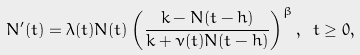<formula> <loc_0><loc_0><loc_500><loc_500>N ^ { \prime } ( t ) = \lambda ( t ) N ( t ) \left ( \frac { k - N ( t - h ) } { k + \nu ( t ) N ( t - h ) } \right ) ^ { \beta } , \ t \geq 0 ,</formula> 